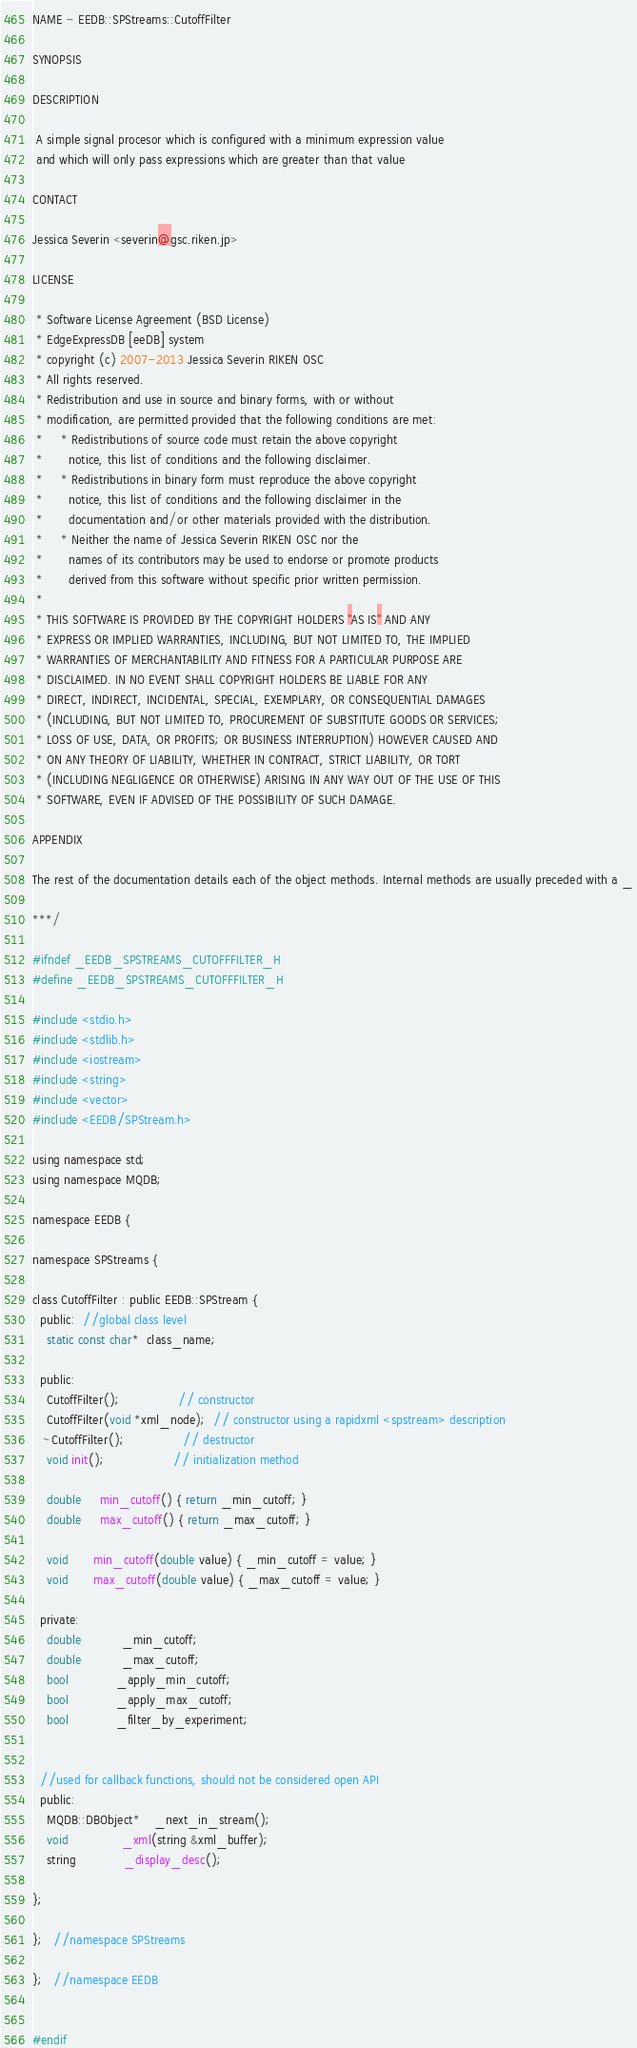Convert code to text. <code><loc_0><loc_0><loc_500><loc_500><_C_>NAME - EEDB::SPStreams::CutoffFilter

SYNOPSIS

DESCRIPTION

 A simple signal procesor which is configured with a minimum expression value
 and which will only pass expressions which are greater than that value

CONTACT

Jessica Severin <severin@gsc.riken.jp>

LICENSE

 * Software License Agreement (BSD License)
 * EdgeExpressDB [eeDB] system
 * copyright (c) 2007-2013 Jessica Severin RIKEN OSC
 * All rights reserved.
 * Redistribution and use in source and binary forms, with or without
 * modification, are permitted provided that the following conditions are met:
 *     * Redistributions of source code must retain the above copyright
 *       notice, this list of conditions and the following disclaimer.
 *     * Redistributions in binary form must reproduce the above copyright
 *       notice, this list of conditions and the following disclaimer in the
 *       documentation and/or other materials provided with the distribution.
 *     * Neither the name of Jessica Severin RIKEN OSC nor the
 *       names of its contributors may be used to endorse or promote products
 *       derived from this software without specific prior written permission.
 *
 * THIS SOFTWARE IS PROVIDED BY THE COPYRIGHT HOLDERS ''AS IS'' AND ANY
 * EXPRESS OR IMPLIED WARRANTIES, INCLUDING, BUT NOT LIMITED TO, THE IMPLIED
 * WARRANTIES OF MERCHANTABILITY AND FITNESS FOR A PARTICULAR PURPOSE ARE
 * DISCLAIMED. IN NO EVENT SHALL COPYRIGHT HOLDERS BE LIABLE FOR ANY
 * DIRECT, INDIRECT, INCIDENTAL, SPECIAL, EXEMPLARY, OR CONSEQUENTIAL DAMAGES
 * (INCLUDING, BUT NOT LIMITED TO, PROCUREMENT OF SUBSTITUTE GOODS OR SERVICES;
 * LOSS OF USE, DATA, OR PROFITS; OR BUSINESS INTERRUPTION) HOWEVER CAUSED AND
 * ON ANY THEORY OF LIABILITY, WHETHER IN CONTRACT, STRICT LIABILITY, OR TORT
 * (INCLUDING NEGLIGENCE OR OTHERWISE) ARISING IN ANY WAY OUT OF THE USE OF THIS
 * SOFTWARE, EVEN IF ADVISED OF THE POSSIBILITY OF SUCH DAMAGE.

APPENDIX

The rest of the documentation details each of the object methods. Internal methods are usually preceded with a _

***/

#ifndef _EEDB_SPSTREAMS_CUTOFFFILTER_H
#define _EEDB_SPSTREAMS_CUTOFFFILTER_H

#include <stdio.h>
#include <stdlib.h>
#include <iostream>
#include <string>
#include <vector>
#include <EEDB/SPStream.h>

using namespace std;
using namespace MQDB;

namespace EEDB {

namespace SPStreams {

class CutoffFilter : public EEDB::SPStream {
  public:  //global class level
    static const char*  class_name;

  public:
    CutoffFilter();                // constructor
    CutoffFilter(void *xml_node);  // constructor using a rapidxml <spstream> description
   ~CutoffFilter();                // destructor
    void init();                   // initialization method

    double     min_cutoff() { return _min_cutoff; }
    double     max_cutoff() { return _max_cutoff; }
  
    void       min_cutoff(double value) { _min_cutoff = value; }
    void       max_cutoff(double value) { _max_cutoff = value; }

  private:
    double           _min_cutoff;
    double           _max_cutoff;
    bool             _apply_min_cutoff;
    bool             _apply_max_cutoff;
    bool             _filter_by_experiment;
    

  //used for callback functions, should not be considered open API
  public:
    MQDB::DBObject*    _next_in_stream();
    void               _xml(string &xml_buffer);
    string             _display_desc();

};

};   //namespace SPStreams

};   //namespace EEDB


#endif
</code> 